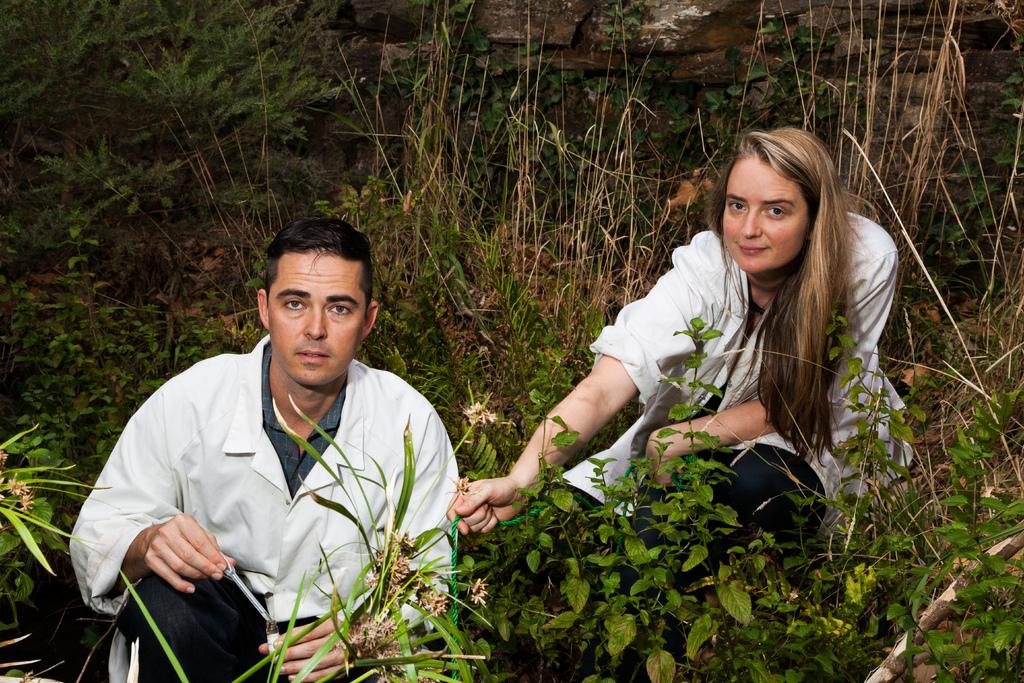Who are the people in the image? There is a man and a woman in the image. Where are the man and woman located in the image? The man and woman are in the middle of the image. What can be seen in the background of the image? There are plants in the background of the image. How are the plants positioned in the image? The plants are on the ground in the background. What is the value of the iron in the image? There is no iron present in the image, so it is not possible to determine its value. 